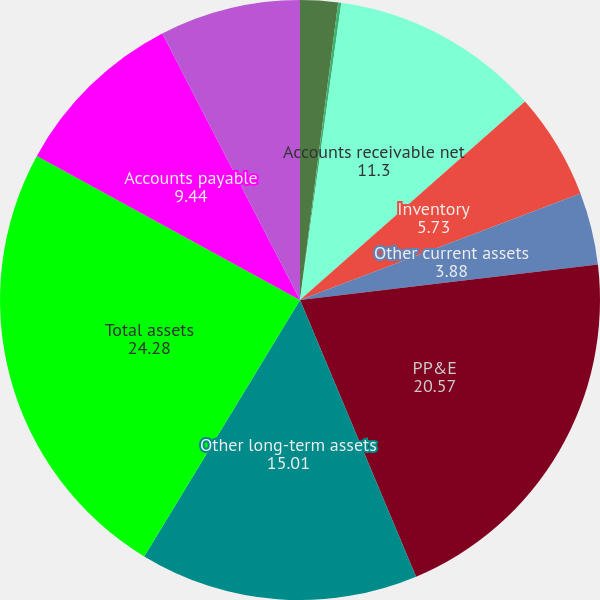<chart> <loc_0><loc_0><loc_500><loc_500><pie_chart><fcel>Cash-unrestricted<fcel>Cash-restricted<fcel>Accounts receivable net<fcel>Inventory<fcel>Other current assets<fcel>PP&E<fcel>Other long-term assets<fcel>Total assets<fcel>Accounts payable<fcel>Current portion of long-term<nl><fcel>2.03%<fcel>0.17%<fcel>11.3%<fcel>5.73%<fcel>3.88%<fcel>20.57%<fcel>15.01%<fcel>24.28%<fcel>9.44%<fcel>7.59%<nl></chart> 